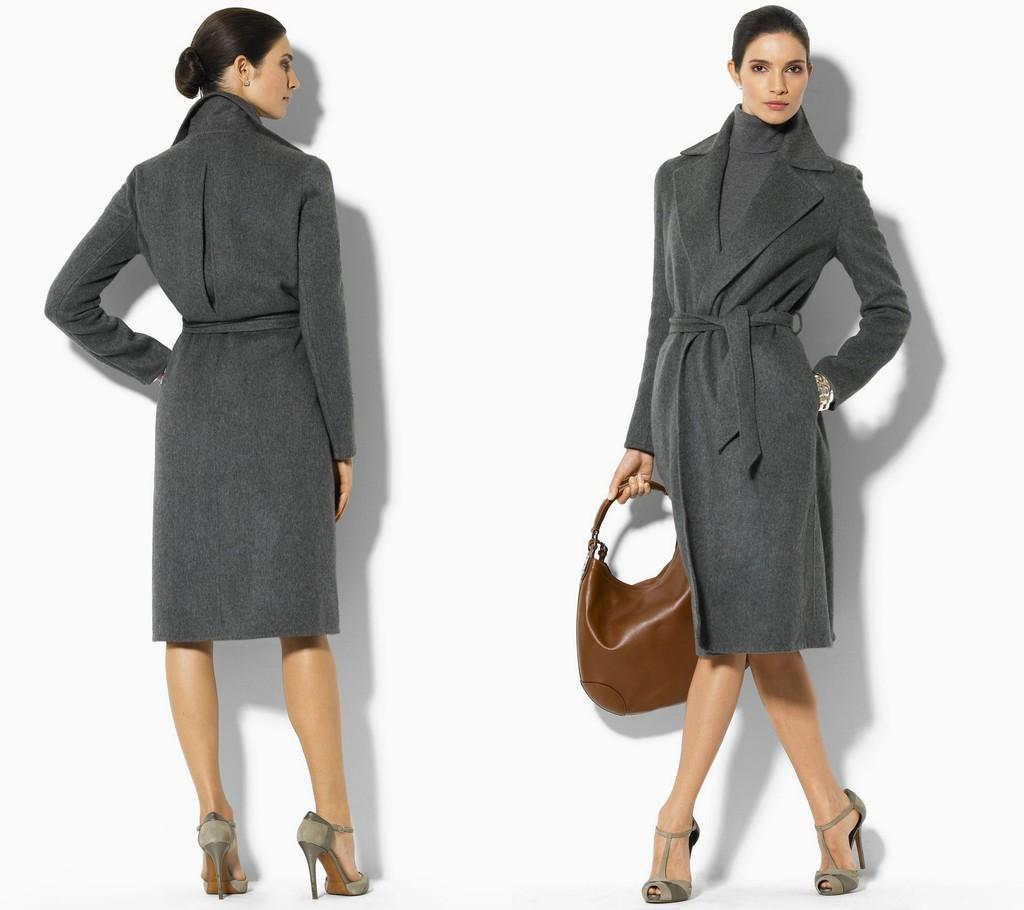How would you summarize this image in a sentence or two? In this image I can see two persons wearing grey color dress and one person holding the brown color bag. And there is a white background. 